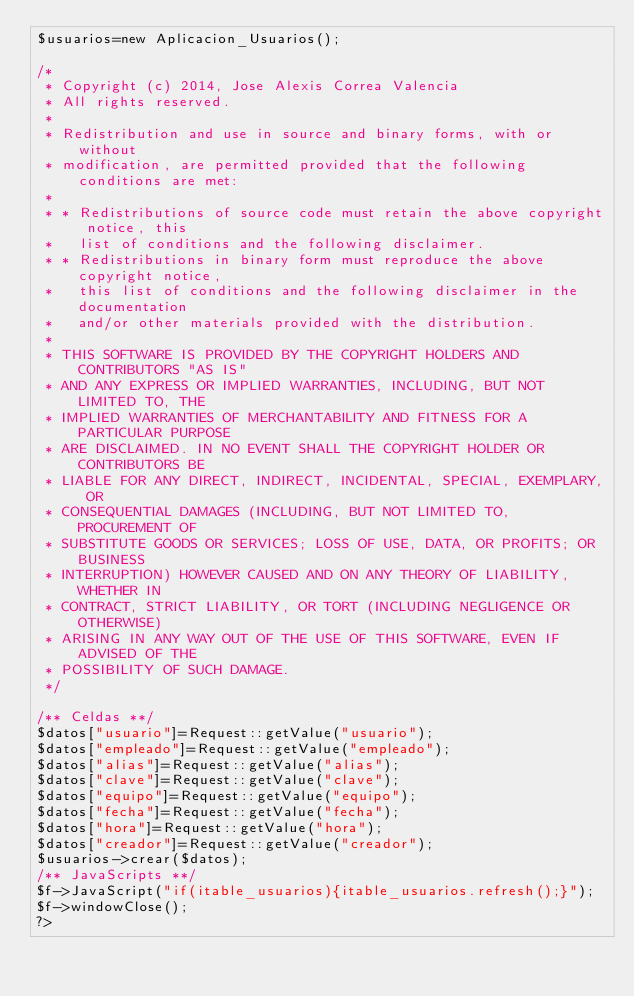Convert code to text. <code><loc_0><loc_0><loc_500><loc_500><_PHP_>$usuarios=new Aplicacion_Usuarios();

/* 
 * Copyright (c) 2014, Jose Alexis Correa Valencia
 * All rights reserved.
 *
 * Redistribution and use in source and binary forms, with or without
 * modification, are permitted provided that the following conditions are met:
 *
 * * Redistributions of source code must retain the above copyright notice, this
 *   list of conditions and the following disclaimer.
 * * Redistributions in binary form must reproduce the above copyright notice,
 *   this list of conditions and the following disclaimer in the documentation
 *   and/or other materials provided with the distribution.
 *
 * THIS SOFTWARE IS PROVIDED BY THE COPYRIGHT HOLDERS AND CONTRIBUTORS "AS IS"
 * AND ANY EXPRESS OR IMPLIED WARRANTIES, INCLUDING, BUT NOT LIMITED TO, THE
 * IMPLIED WARRANTIES OF MERCHANTABILITY AND FITNESS FOR A PARTICULAR PURPOSE
 * ARE DISCLAIMED. IN NO EVENT SHALL THE COPYRIGHT HOLDER OR CONTRIBUTORS BE
 * LIABLE FOR ANY DIRECT, INDIRECT, INCIDENTAL, SPECIAL, EXEMPLARY, OR
 * CONSEQUENTIAL DAMAGES (INCLUDING, BUT NOT LIMITED TO, PROCUREMENT OF
 * SUBSTITUTE GOODS OR SERVICES; LOSS OF USE, DATA, OR PROFITS; OR BUSINESS
 * INTERRUPTION) HOWEVER CAUSED AND ON ANY THEORY OF LIABILITY, WHETHER IN
 * CONTRACT, STRICT LIABILITY, OR TORT (INCLUDING NEGLIGENCE OR OTHERWISE)
 * ARISING IN ANY WAY OUT OF THE USE OF THIS SOFTWARE, EVEN IF ADVISED OF THE
 * POSSIBILITY OF SUCH DAMAGE.
 */

/** Celdas **/
$datos["usuario"]=Request::getValue("usuario");
$datos["empleado"]=Request::getValue("empleado");
$datos["alias"]=Request::getValue("alias");
$datos["clave"]=Request::getValue("clave");
$datos["equipo"]=Request::getValue("equipo");
$datos["fecha"]=Request::getValue("fecha");
$datos["hora"]=Request::getValue("hora");
$datos["creador"]=Request::getValue("creador");
$usuarios->crear($datos);
/** JavaScripts **/
$f->JavaScript("if(itable_usuarios){itable_usuarios.refresh();}");
$f->windowClose();
?></code> 